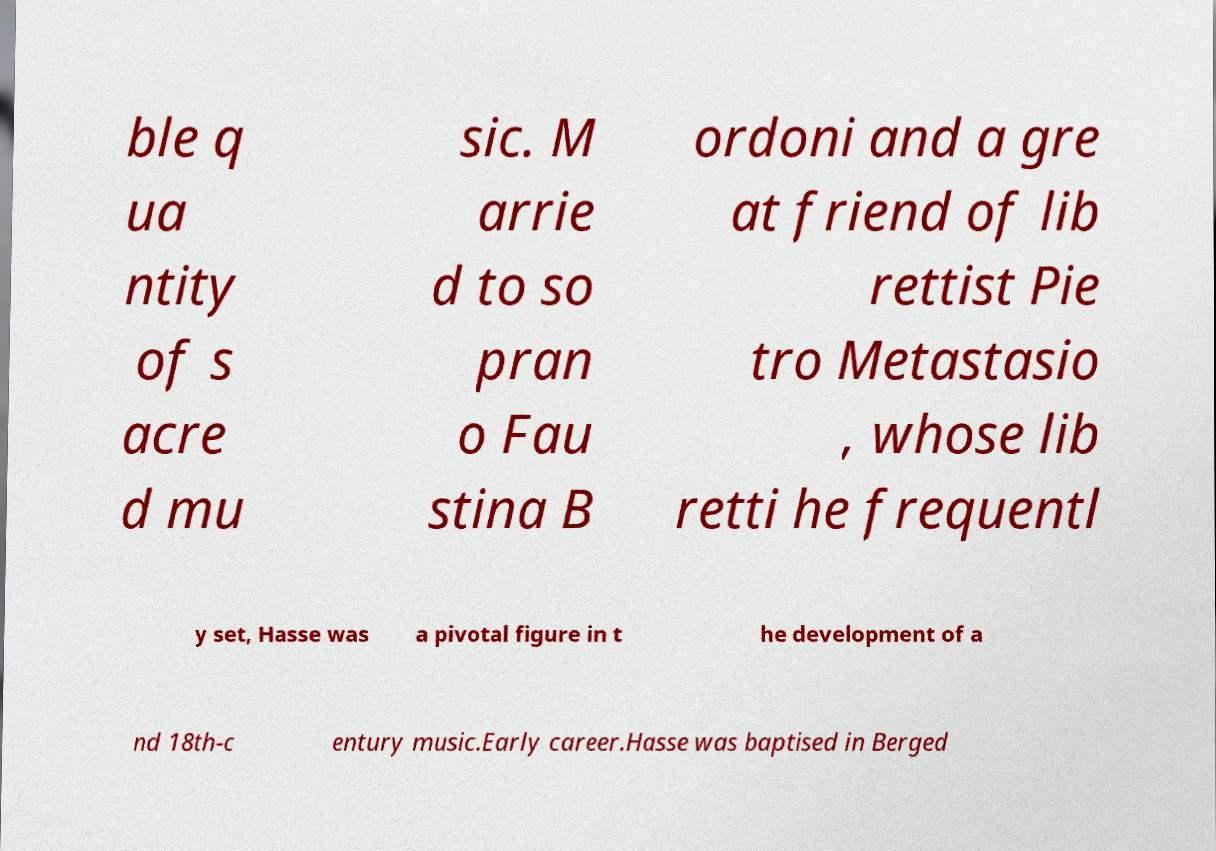Could you extract and type out the text from this image? ble q ua ntity of s acre d mu sic. M arrie d to so pran o Fau stina B ordoni and a gre at friend of lib rettist Pie tro Metastasio , whose lib retti he frequentl y set, Hasse was a pivotal figure in t he development of a nd 18th-c entury music.Early career.Hasse was baptised in Berged 